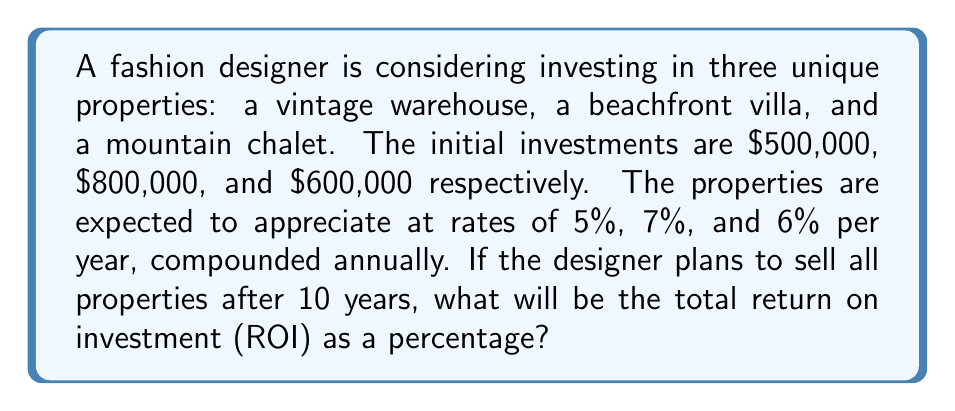Help me with this question. Let's approach this problem step by step:

1) First, we need to calculate the future value of each property after 10 years using the compound interest formula:

   $A = P(1 + r)^n$

   Where:
   $A$ = Final amount
   $P$ = Principal (initial investment)
   $r$ = Annual interest rate (appreciation rate)
   $n$ = Number of years

2) For the vintage warehouse:
   $A_1 = 500,000(1 + 0.05)^{10} = 500,000(1.6289) = 814,450$

3) For the beachfront villa:
   $A_2 = 800,000(1 + 0.07)^{10} = 800,000(1.9672) = 1,573,760$

4) For the mountain chalet:
   $A_3 = 600,000(1 + 0.06)^{10} = 600,000(1.7908) = 1,074,480$

5) Total value after 10 years:
   $Total_A = 814,450 + 1,573,760 + 1,074,480 = 3,462,690$

6) Total initial investment:
   $Total_P = 500,000 + 800,000 + 600,000 = 1,900,000$

7) To calculate ROI as a percentage:

   $ROI = \frac{Gain\ from\ Investment}{Cost\ of\ Investment} \times 100\%$

   $ROI = \frac{Total_A - Total_P}{Total_P} \times 100\%$

   $ROI = \frac{3,462,690 - 1,900,000}{1,900,000} \times 100\%$

   $ROI = \frac{1,562,690}{1,900,000} \times 100\% = 82.25\%$
Answer: The total return on investment (ROI) after 10 years would be approximately 82.25%. 